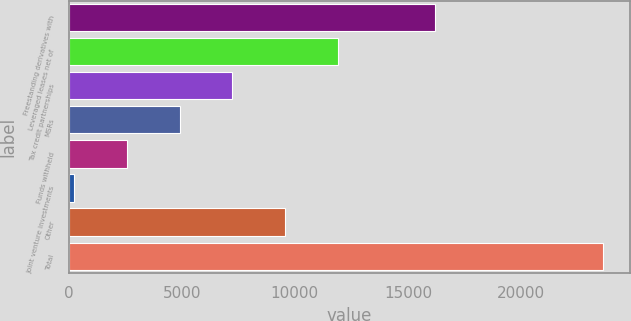Convert chart. <chart><loc_0><loc_0><loc_500><loc_500><bar_chart><fcel>Freestanding derivatives with<fcel>Leveraged leases net of<fcel>Tax credit partnerships<fcel>MSRs<fcel>Funds withheld<fcel>Joint venture investments<fcel>Other<fcel>Total<nl><fcel>16200<fcel>11923<fcel>7241<fcel>4900<fcel>2559<fcel>218<fcel>9582<fcel>23628<nl></chart> 